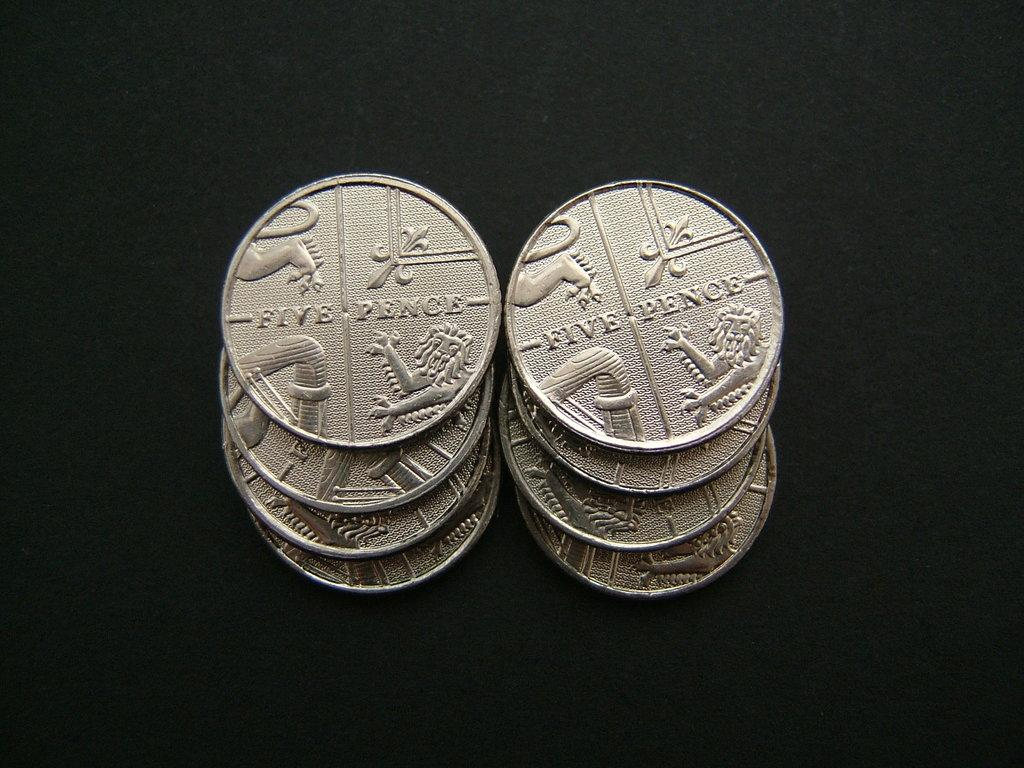Provide a one-sentence caption for the provided image. The coins that are stacked up have the value of five pence. 